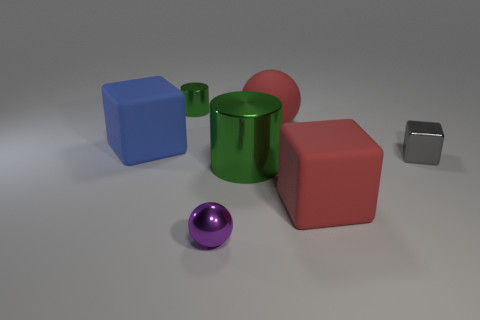Add 1 small blue metal things. How many objects exist? 8 Subtract all cubes. How many objects are left? 4 Subtract all big matte things. Subtract all red blocks. How many objects are left? 3 Add 1 large red spheres. How many large red spheres are left? 2 Add 5 tiny red metallic cylinders. How many tiny red metallic cylinders exist? 5 Subtract 1 red balls. How many objects are left? 6 